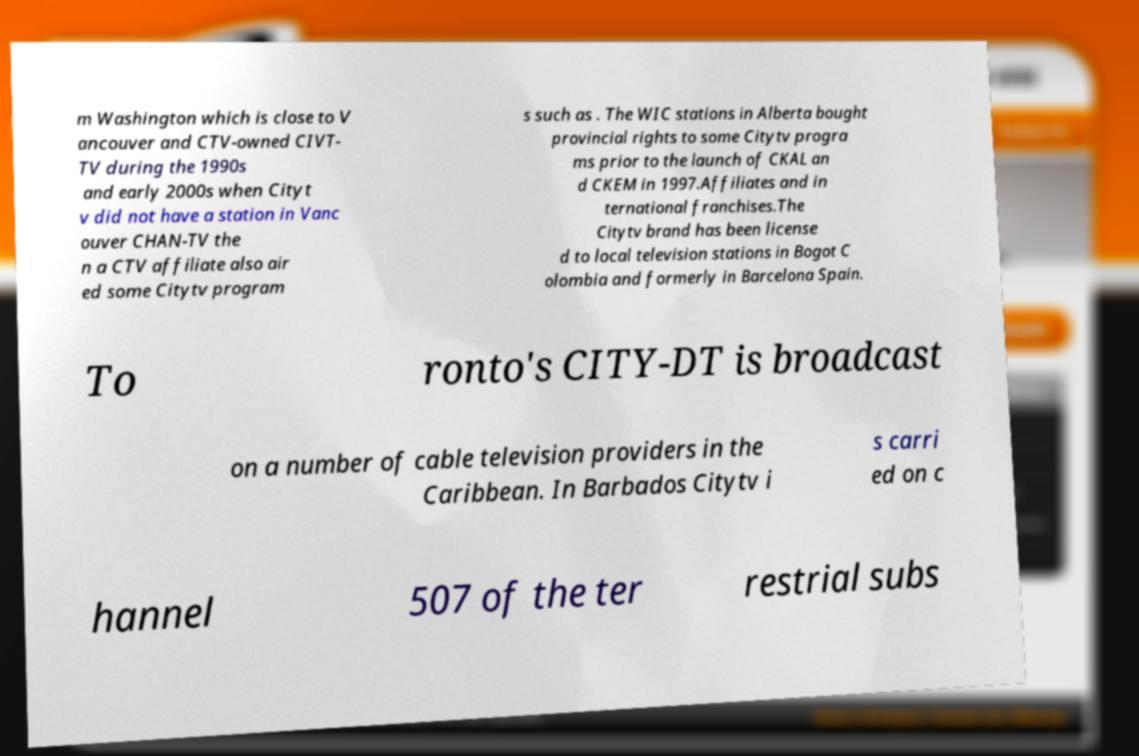For documentation purposes, I need the text within this image transcribed. Could you provide that? m Washington which is close to V ancouver and CTV-owned CIVT- TV during the 1990s and early 2000s when Cityt v did not have a station in Vanc ouver CHAN-TV the n a CTV affiliate also air ed some Citytv program s such as . The WIC stations in Alberta bought provincial rights to some Citytv progra ms prior to the launch of CKAL an d CKEM in 1997.Affiliates and in ternational franchises.The Citytv brand has been license d to local television stations in Bogot C olombia and formerly in Barcelona Spain. To ronto's CITY-DT is broadcast on a number of cable television providers in the Caribbean. In Barbados Citytv i s carri ed on c hannel 507 of the ter restrial subs 